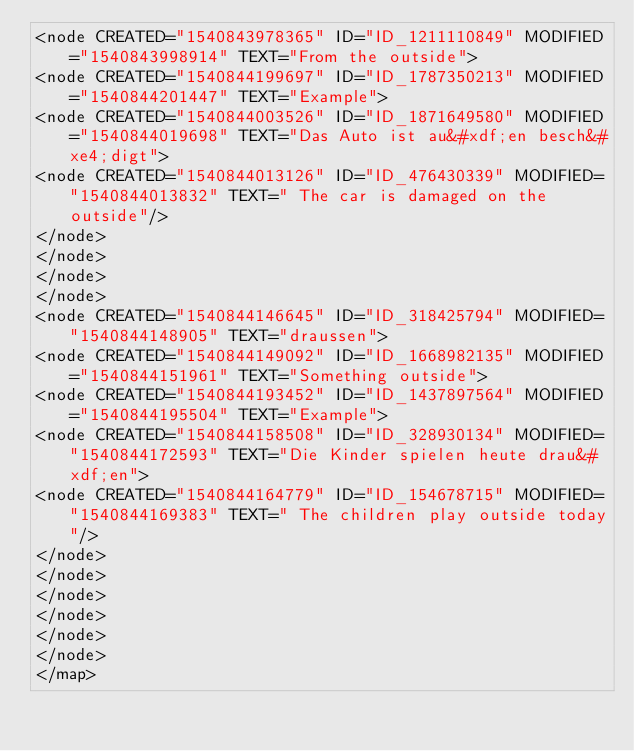<code> <loc_0><loc_0><loc_500><loc_500><_ObjectiveC_><node CREATED="1540843978365" ID="ID_1211110849" MODIFIED="1540843998914" TEXT="From the outside">
<node CREATED="1540844199697" ID="ID_1787350213" MODIFIED="1540844201447" TEXT="Example">
<node CREATED="1540844003526" ID="ID_1871649580" MODIFIED="1540844019698" TEXT="Das Auto ist au&#xdf;en besch&#xe4;digt">
<node CREATED="1540844013126" ID="ID_476430339" MODIFIED="1540844013832" TEXT=" The car is damaged on the outside"/>
</node>
</node>
</node>
</node>
<node CREATED="1540844146645" ID="ID_318425794" MODIFIED="1540844148905" TEXT="draussen">
<node CREATED="1540844149092" ID="ID_1668982135" MODIFIED="1540844151961" TEXT="Something outside">
<node CREATED="1540844193452" ID="ID_1437897564" MODIFIED="1540844195504" TEXT="Example">
<node CREATED="1540844158508" ID="ID_328930134" MODIFIED="1540844172593" TEXT="Die Kinder spielen heute drau&#xdf;en">
<node CREATED="1540844164779" ID="ID_154678715" MODIFIED="1540844169383" TEXT=" The children play outside today"/>
</node>
</node>
</node>
</node>
</node>
</node>
</map>
</code> 